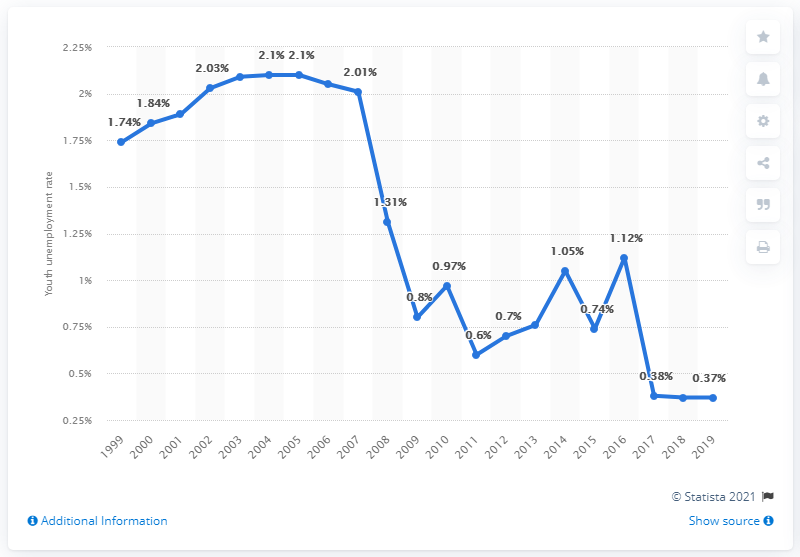Highlight a few significant elements in this photo. According to data from 2019, the youth unemployment rate in Cambodia was 0.37%. 